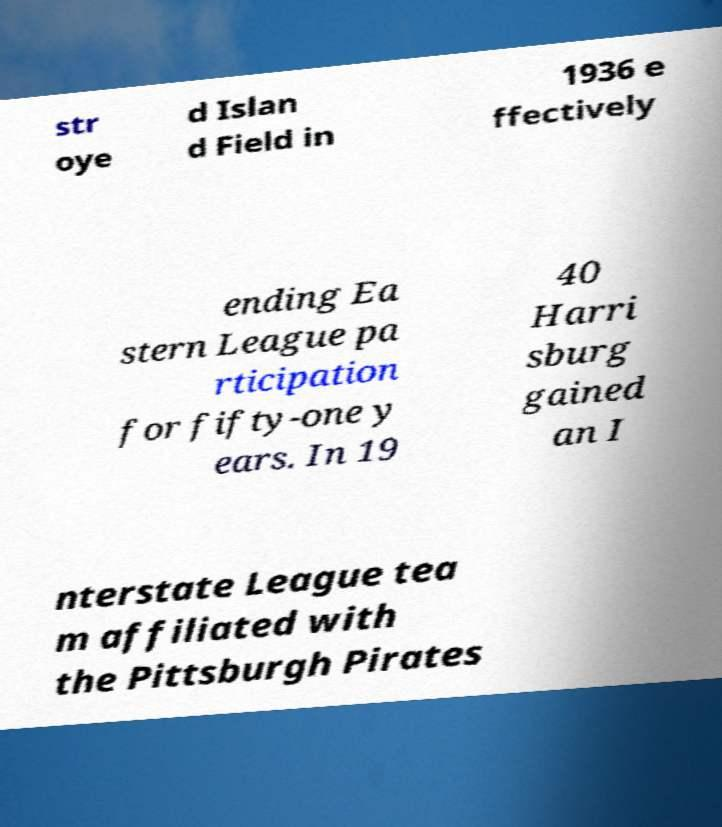Please read and relay the text visible in this image. What does it say? str oye d Islan d Field in 1936 e ffectively ending Ea stern League pa rticipation for fifty-one y ears. In 19 40 Harri sburg gained an I nterstate League tea m affiliated with the Pittsburgh Pirates 